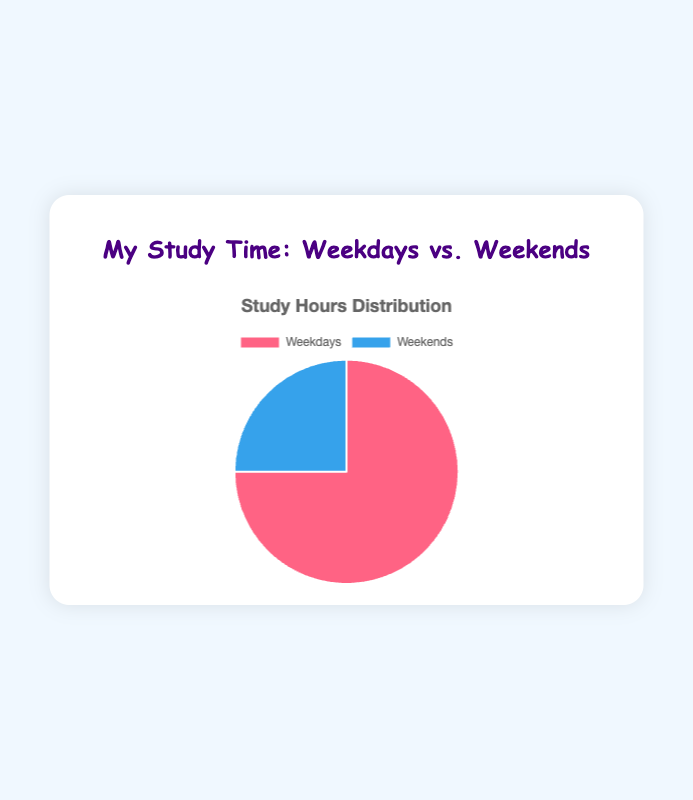What percentage of the total study hours is spent on weekdays? There are 15 study hours on weekdays and 5 on weekends. The total study hours are 15 + 5 = 20. The percentage of total study hours spent on weekdays is (15/20) * 100 = 75%.
Answer: 75% How much more time is spent studying on weekdays compared to weekends? Weekdays have 15 hours of study time, and weekends have 5. The difference is 15 - 5 = 10 hours.
Answer: 10 hours Which part of the week has more study hours? By looking at the pie chart, the segment labeled 'Weekdays' is larger than 'Weekends'.
Answer: Weekdays If the total study time was increased by 10 hours and evenly distributed to weekdays and weekends, what would be the new total hours for each? If 10 hours are added and evenly split, each part gets 10/2 = 5 more hours. Thus, weekdays would have 15 + 5 = 20 hours and weekends 5 + 5 = 10 hours.
Answer: Weekdays: 20 hours, Weekends: 10 hours What color represents the study time on weekends in the pie chart? According to the chart, the study time on weekends is represented by blue.
Answer: Blue If the weekly study hours were to be redistributed such that both weekdays and weekends had an equal amount of study time, how many hours would each receive? The total amount of hours is 20 (from 15 weekdays + 5 weekends). To distribute equally, each would get 20/2 = 10 hours.
Answer: 10 hours What is the ratio of study hours on weekdays to weekends? The study hours are 15 for weekdays and 5 for weekends. The ratio is 15:5, which simplifies to 3:1.
Answer: 3:1 What is the combined percentage of study hours spent on weekends and a quarter of the time on weekdays? Time spent on weekends is 5 hours (25%), and a quarter of weekdays is 15/4 = 3.75 hours. Total hours considered = 5 + 3.75 = 8.75. As a percentage of the total 20 hours, (8.75/20) * 100 = 43.75%.
Answer: 43.75% How would the pie chart visually change if the study hours on weekends were tripled? If weekend hours are tripled, they become 5 * 3 = 15 hours. Now, both segments (weekdays and weekends) are 15 hours each, so the pie chart will show them as equal halves.
Answer: Equal halves 